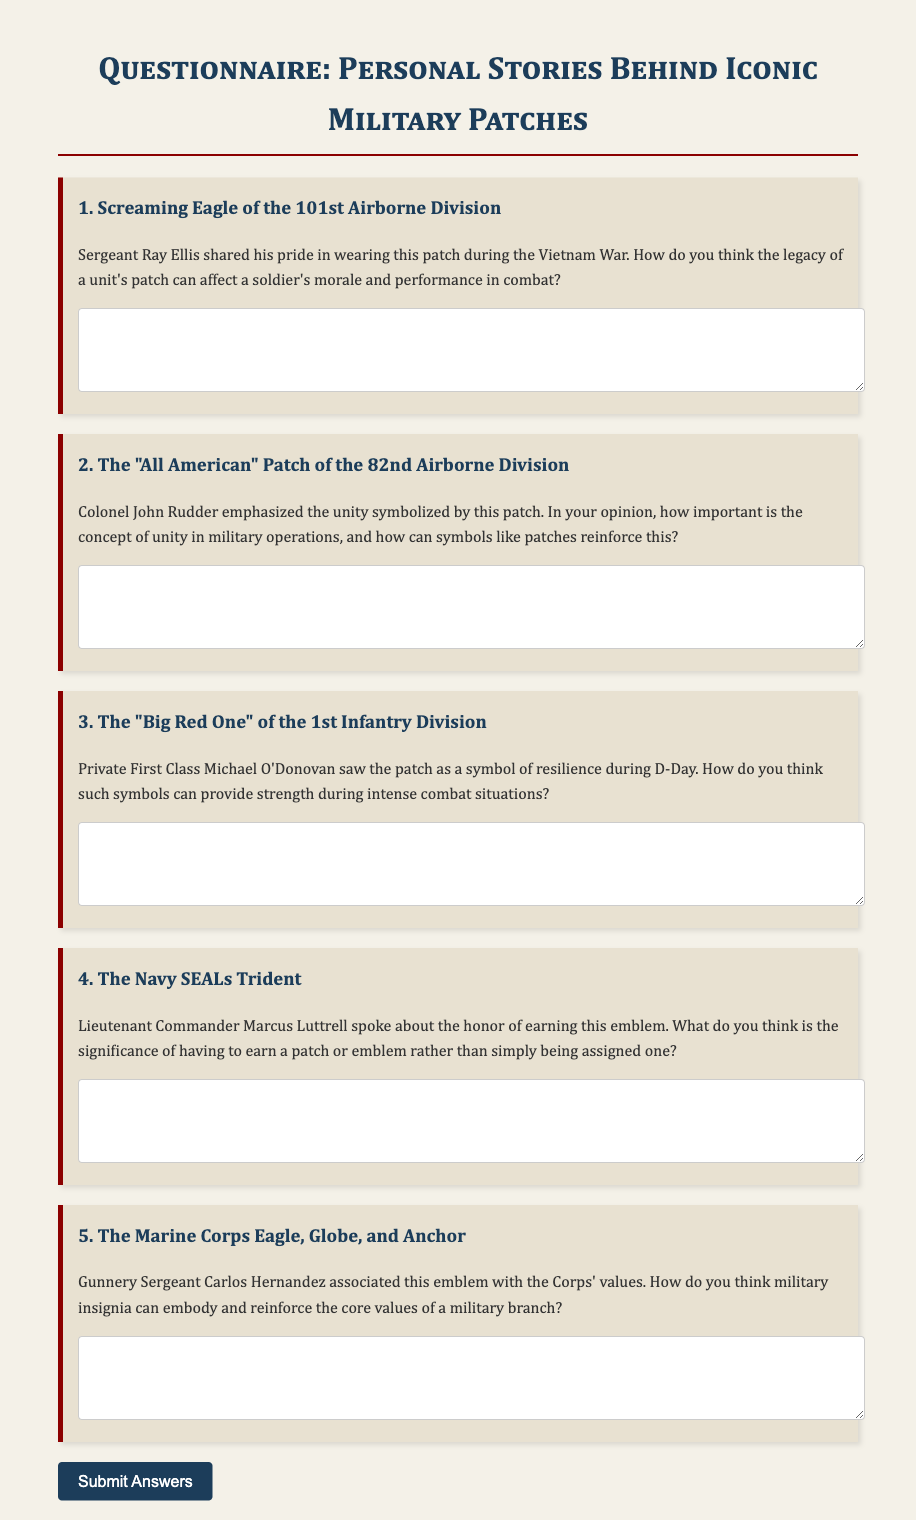What is the title of the document? The title of the document is stated in the HTML as "Military Patch Questionnaire."
Answer: Military Patch Questionnaire How many questions are in the questionnaire? The document contains five distinct questions regarding military patches.
Answer: Five Who shared their story about the Screaming Eagle patch? The document highlights a story shared by Sergeant Ray Ellis regarding his experience during the Vietnam War.
Answer: Sergeant Ray Ellis Which division does the "All American" patch represent? The question in the document clarifies that the "All American" patch belongs to the 82nd Airborne Division.
Answer: 82nd Airborne Division What does Lieutenant Commander Marcus Luttrell speak about? The document mentions that he discusses the honor of earning the Navy SEALs Trident emblem.
Answer: The honor of earning the Navy SEALs Trident According to the document, which emblem is associated with the Corps' values? The questionnaire states that the Marine Corps Eagle, Globe, and Anchor emblem is associated with the Corps' values.
Answer: Marine Corps Eagle, Globe, and Anchor What is required for a soldier to earn the Navy SEALs patch? The document suggests that a soldier must earn the emblem rather than just being assigned one.
Answer: Earn What emotion is linked to the Big Red One patch during D-Day? Private First Class Michael O'Donovan associated the patch with resilience during D-Day combat.
Answer: Resilience 